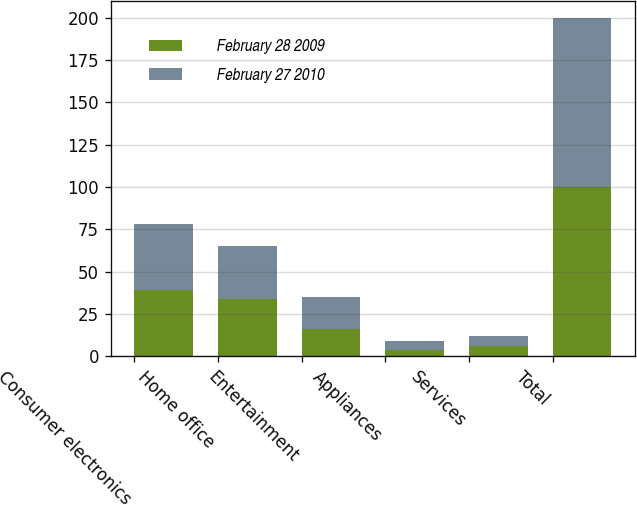<chart> <loc_0><loc_0><loc_500><loc_500><stacked_bar_chart><ecel><fcel>Consumer electronics<fcel>Home office<fcel>Entertainment<fcel>Appliances<fcel>Services<fcel>Total<nl><fcel>February 28 2009<fcel>39<fcel>34<fcel>16<fcel>4<fcel>6<fcel>100<nl><fcel>February 27 2010<fcel>39<fcel>31<fcel>19<fcel>5<fcel>6<fcel>100<nl></chart> 